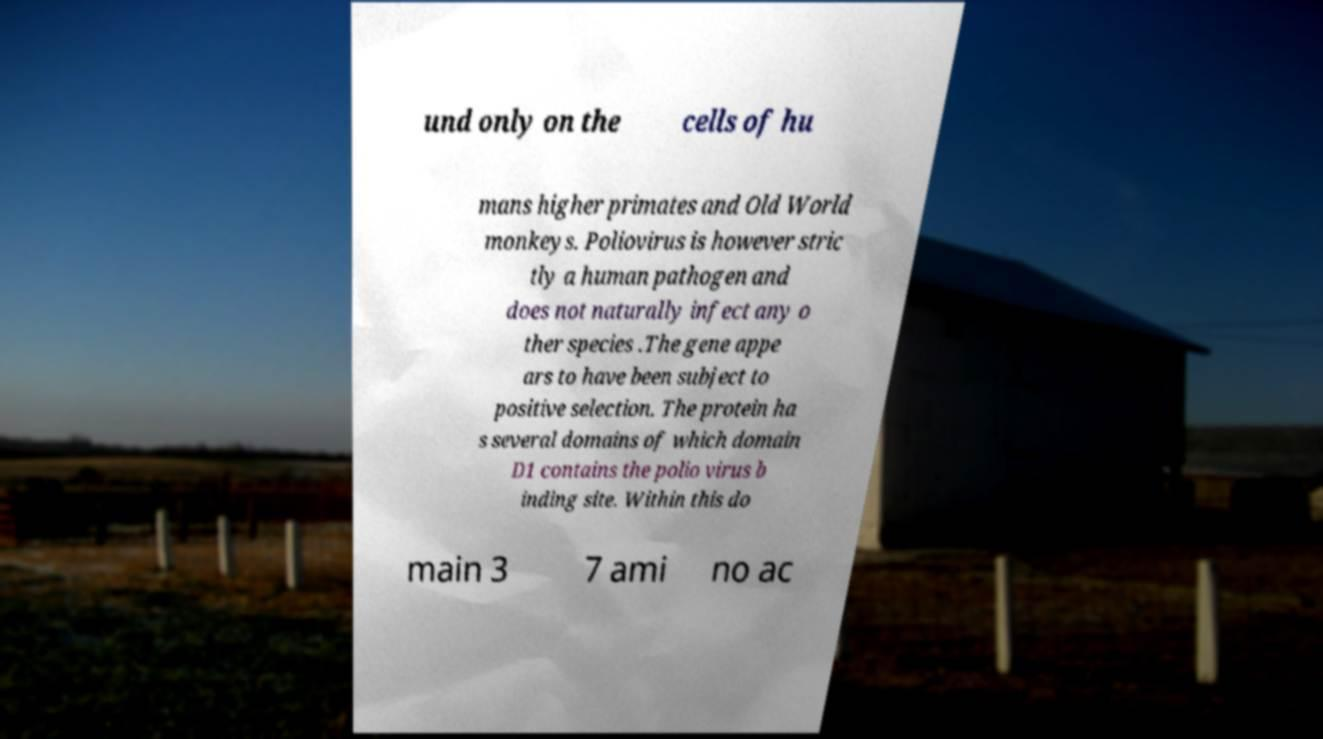Could you assist in decoding the text presented in this image and type it out clearly? und only on the cells of hu mans higher primates and Old World monkeys. Poliovirus is however stric tly a human pathogen and does not naturally infect any o ther species .The gene appe ars to have been subject to positive selection. The protein ha s several domains of which domain D1 contains the polio virus b inding site. Within this do main 3 7 ami no ac 